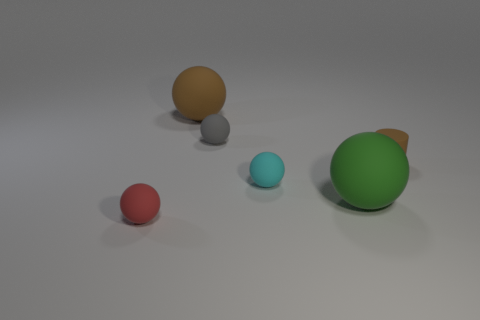Subtract all big spheres. How many spheres are left? 3 Subtract 2 balls. How many balls are left? 3 Subtract all brown balls. How many balls are left? 4 Add 3 tiny green metal blocks. How many objects exist? 9 Subtract all spheres. How many objects are left? 1 Add 1 tiny matte balls. How many tiny matte balls are left? 4 Add 6 large yellow rubber blocks. How many large yellow rubber blocks exist? 6 Subtract 0 purple cubes. How many objects are left? 6 Subtract all brown balls. Subtract all cyan blocks. How many balls are left? 4 Subtract all big matte balls. Subtract all large objects. How many objects are left? 2 